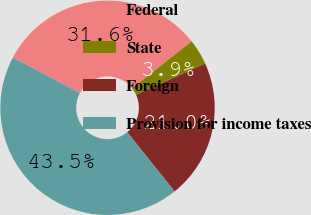Convert chart. <chart><loc_0><loc_0><loc_500><loc_500><pie_chart><fcel>Federal<fcel>State<fcel>Foreign<fcel>Provision for income taxes<nl><fcel>31.59%<fcel>3.87%<fcel>21.01%<fcel>43.54%<nl></chart> 